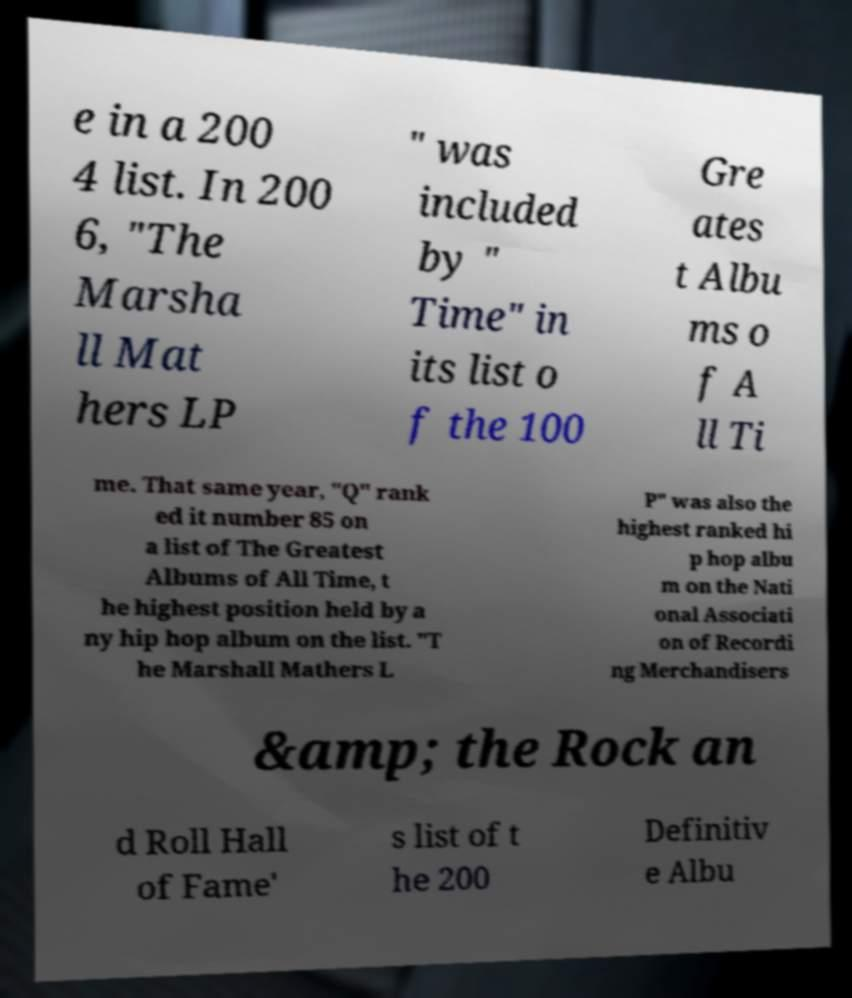Could you assist in decoding the text presented in this image and type it out clearly? e in a 200 4 list. In 200 6, "The Marsha ll Mat hers LP " was included by " Time" in its list o f the 100 Gre ates t Albu ms o f A ll Ti me. That same year, "Q" rank ed it number 85 on a list of The Greatest Albums of All Time, t he highest position held by a ny hip hop album on the list. "T he Marshall Mathers L P" was also the highest ranked hi p hop albu m on the Nati onal Associati on of Recordi ng Merchandisers &amp; the Rock an d Roll Hall of Fame' s list of t he 200 Definitiv e Albu 